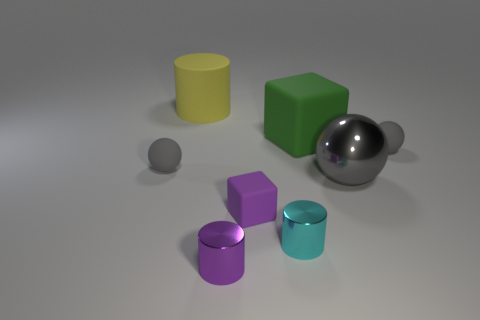Subtract all matte cylinders. How many cylinders are left? 2 Subtract all yellow cylinders. How many cylinders are left? 2 Subtract 1 cylinders. How many cylinders are left? 2 Add 1 tiny gray objects. How many objects exist? 9 Subtract all large balls. Subtract all yellow cylinders. How many objects are left? 6 Add 1 rubber cubes. How many rubber cubes are left? 3 Add 7 tiny purple cylinders. How many tiny purple cylinders exist? 8 Subtract 0 yellow blocks. How many objects are left? 8 Subtract all cylinders. How many objects are left? 5 Subtract all purple cylinders. Subtract all brown blocks. How many cylinders are left? 2 